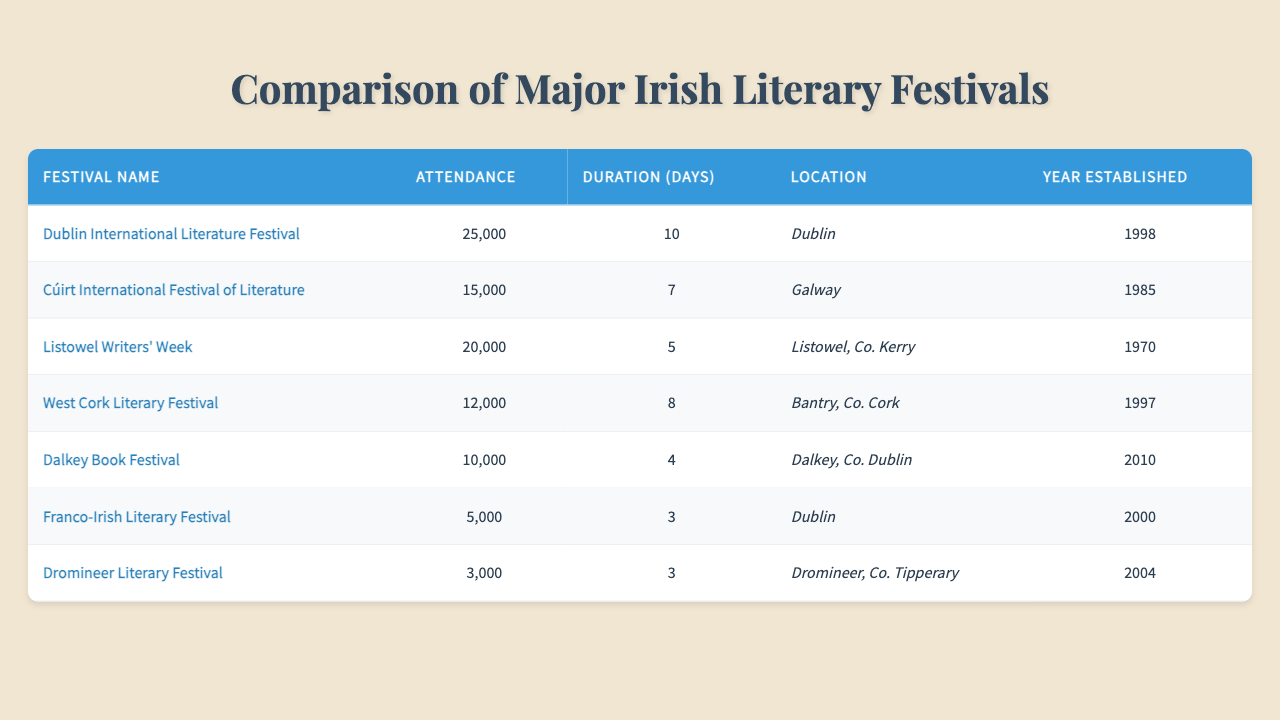What is the name of the festival with the highest attendance? The table lists various festivals along with their attendance figures. By scanning the attendance column, we see that the Dublin International Literature Festival has the highest attendance with 25,000.
Answer: Dublin International Literature Festival Which festival is located in Galway? According to the location column in the table, the Cúirt International Festival of Literature is the one located in Galway.
Answer: Cúirt International Festival of Literature What is the duration of the Dalkey Book Festival? Looking at the duration column for the Dalkey Book Festival, it is indicated that the festival lasts for 4 days.
Answer: 4 How many festivals have an attendance of over 15,000? We need to check each festival's attendance. The festivals with over 15,000 attendees are: Dublin International Literature Festival (25,000), Listowel Writers' Week (20,000), and Cúirt International Festival of Literature (15,000). Hence, there are three festivals in total.
Answer: 3 What is the average attendance of all festivals? We first sum the attendance numbers: 25,000 + 15,000 + 20,000 + 12,000 + 10,000 + 5,000 + 3,000 = 100,000. There are 7 festivals, so we divide the total attendance by the number of festivals: 100,000 / 7 equals approximately 14,286.
Answer: 14,286 Which festival has the longest duration, and how many days does it last? We examine the duration column across the festivals. The festival with the longest duration is the Dublin International Literature Festival with a duration of 10 days.
Answer: 10 days Is the Franco-Irish Literary Festival established before the Listowel Writers' Week? Checking the year established column, the Franco-Irish Literary Festival was established in 2000, while the Listowel Writers' Week was established in 1970. Thus, the Franco-Irish Literary Festival is not older.
Answer: No How many more attendees did the Dublin International Literature Festival have compared to the Dalkey Book Festival? We find the attendance values: Dublin International Literature Festival has 25,000 attendees, and Dalkey Book Festival has 10,000. The difference is 25,000 - 10,000 = 15,000.
Answer: 15,000 What percentage of the total attendance does the West Cork Literary Festival represent? First, we need the total attendance, which is 100,000. The West Cork Literary Festival has an attendance of 12,000. We calculate the percentage: (12,000 / 100,000) * 100 = 12%.
Answer: 12% 